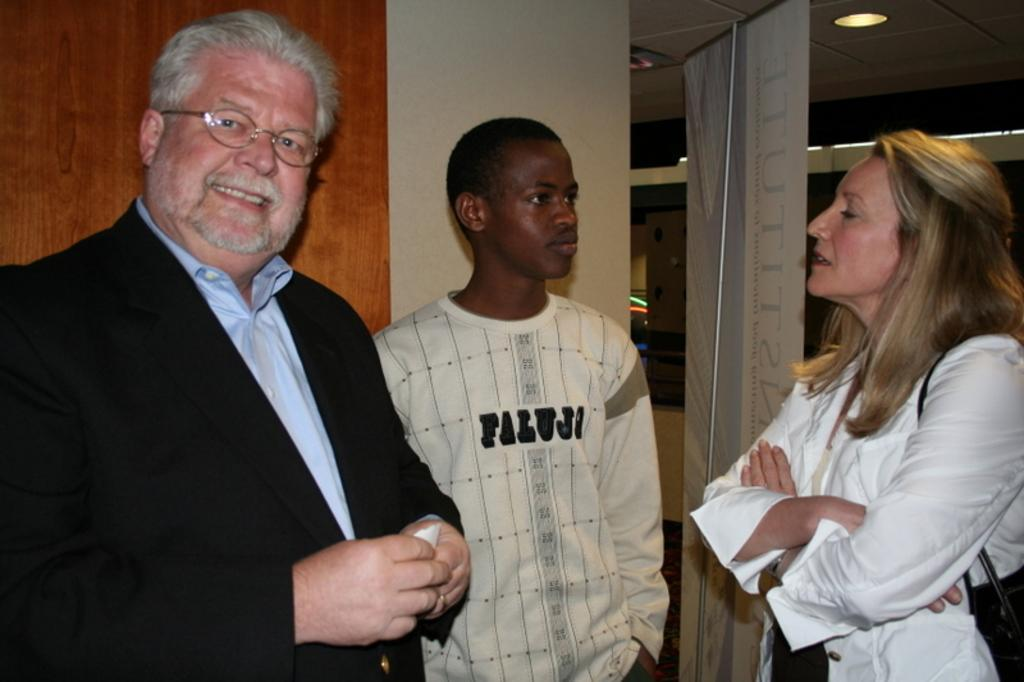How many people are in the image? There are three people standing in the image. What is the woman carrying in the image? The woman is carrying a bag in the image. What can be seen hanging or displayed in the image? There is a banner visible in the image. What type of structure is present in the image? There is a wall in the image. What is present at the top of the image? Lights and a ceiling are present at the top of the image. How many fingers does the wheel have in the image? There is no wheel present in the image, so it is not possible to determine the number of fingers it might have. 